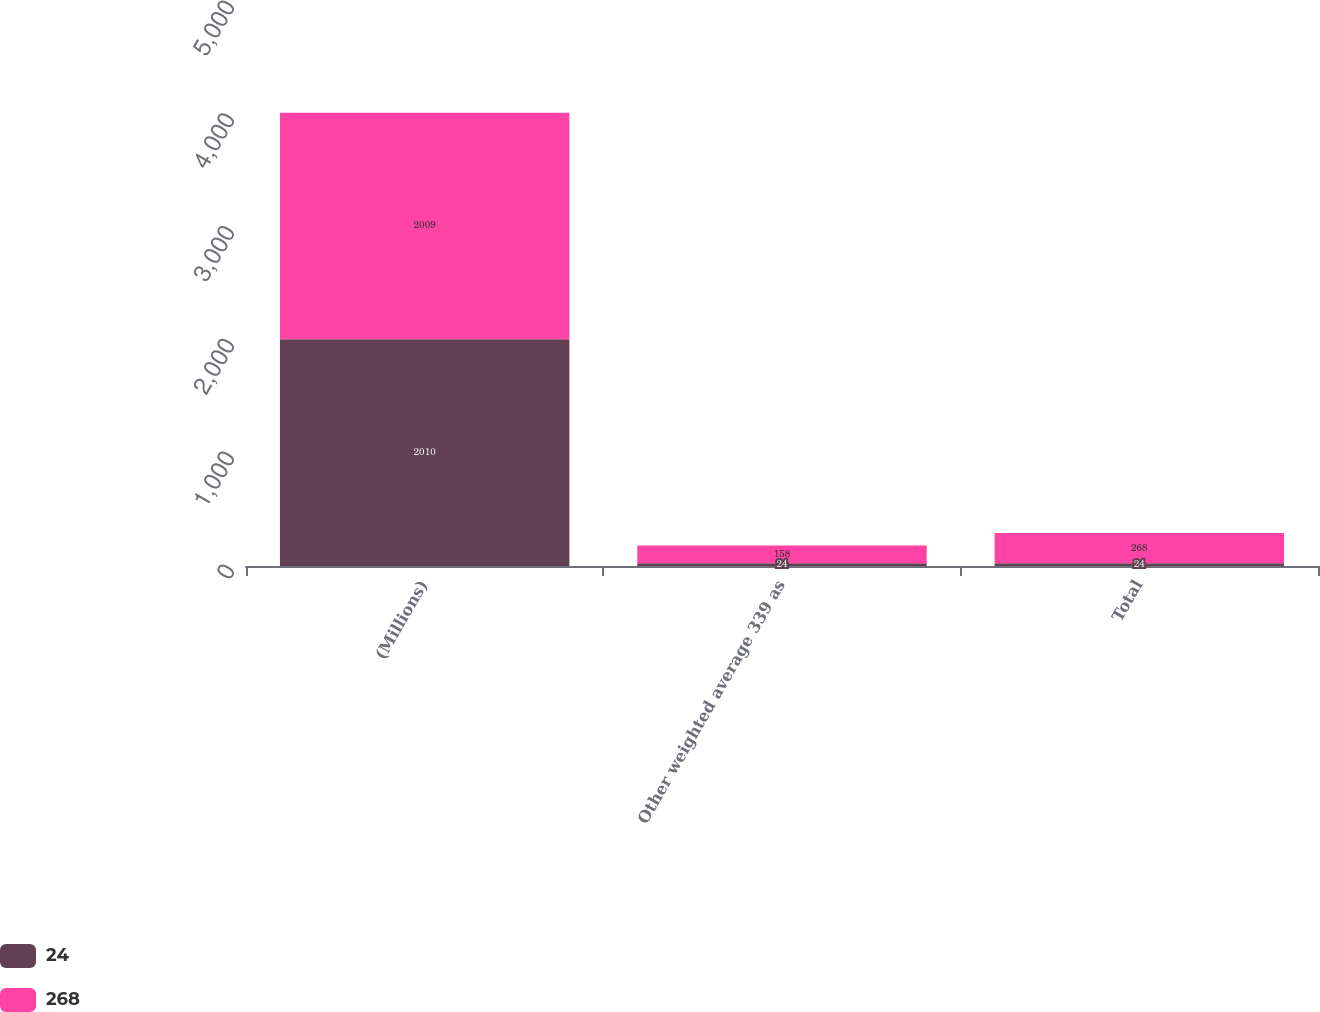<chart> <loc_0><loc_0><loc_500><loc_500><stacked_bar_chart><ecel><fcel>(Millions)<fcel>Other weighted average 339 as<fcel>Total<nl><fcel>24<fcel>2010<fcel>24<fcel>24<nl><fcel>268<fcel>2009<fcel>158<fcel>268<nl></chart> 